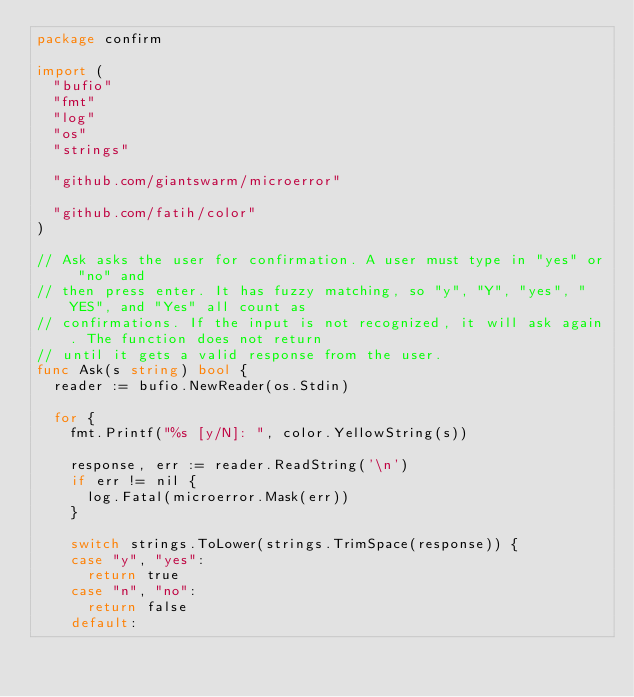<code> <loc_0><loc_0><loc_500><loc_500><_Go_>package confirm

import (
	"bufio"
	"fmt"
	"log"
	"os"
	"strings"

	"github.com/giantswarm/microerror"

	"github.com/fatih/color"
)

// Ask asks the user for confirmation. A user must type in "yes" or "no" and
// then press enter. It has fuzzy matching, so "y", "Y", "yes", "YES", and "Yes" all count as
// confirmations. If the input is not recognized, it will ask again. The function does not return
// until it gets a valid response from the user.
func Ask(s string) bool {
	reader := bufio.NewReader(os.Stdin)

	for {
		fmt.Printf("%s [y/N]: ", color.YellowString(s))

		response, err := reader.ReadString('\n')
		if err != nil {
			log.Fatal(microerror.Mask(err))
		}

		switch strings.ToLower(strings.TrimSpace(response)) {
		case "y", "yes":
			return true
		case "n", "no":
			return false
		default:</code> 